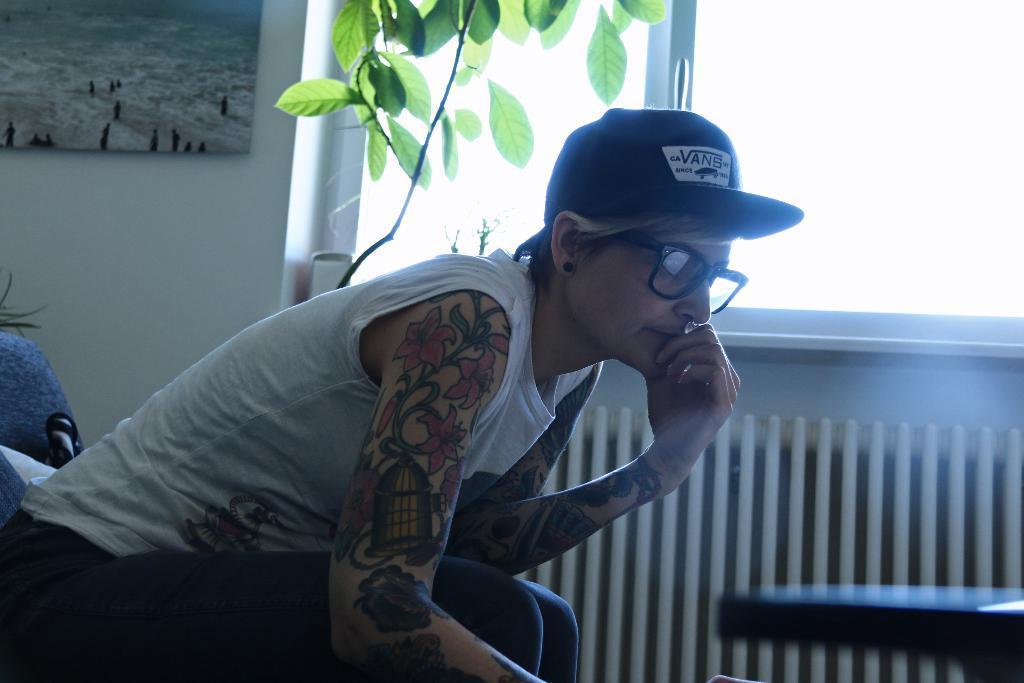Describe this image in one or two sentences. In this picture there is a lady on the left side of the image, on a sofa and there is a portrait and a plant at the top side of the image, there is a window in the center of the image. 